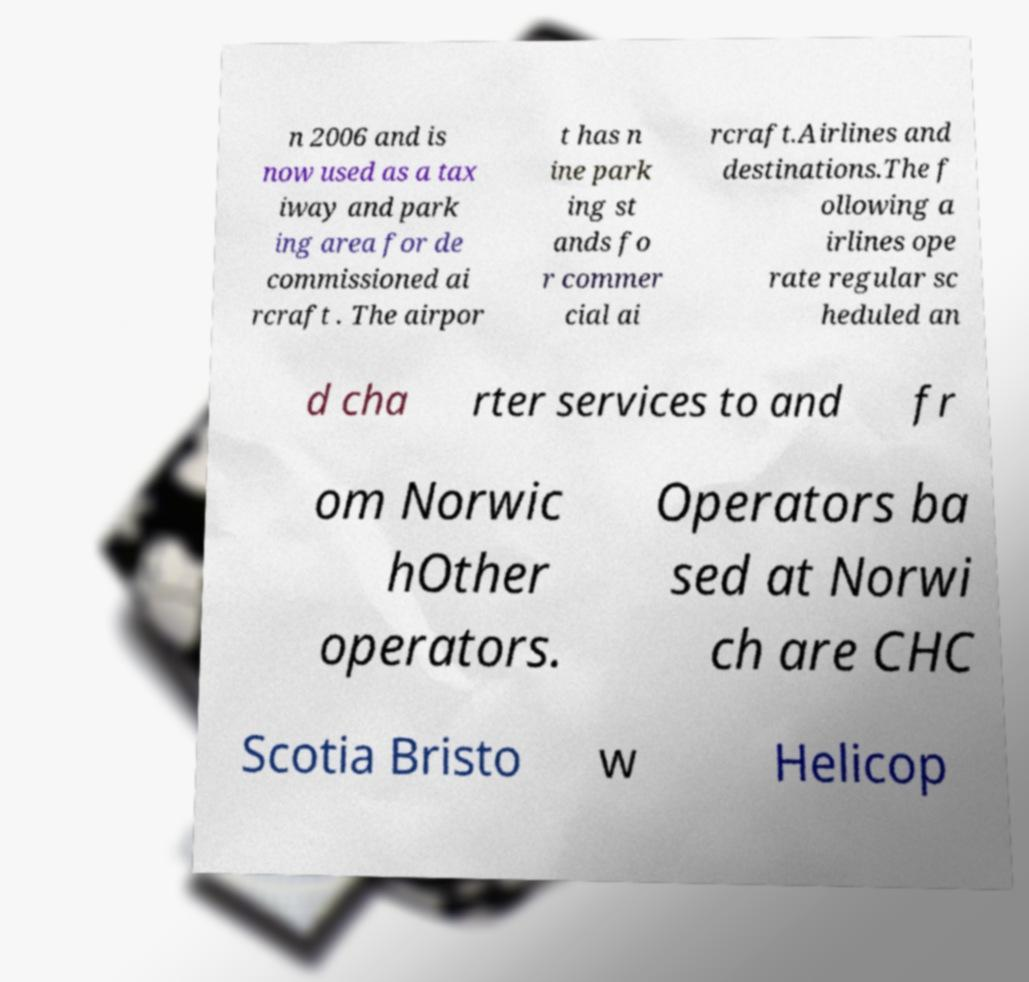Please identify and transcribe the text found in this image. n 2006 and is now used as a tax iway and park ing area for de commissioned ai rcraft . The airpor t has n ine park ing st ands fo r commer cial ai rcraft.Airlines and destinations.The f ollowing a irlines ope rate regular sc heduled an d cha rter services to and fr om Norwic hOther operators. Operators ba sed at Norwi ch are CHC Scotia Bristo w Helicop 